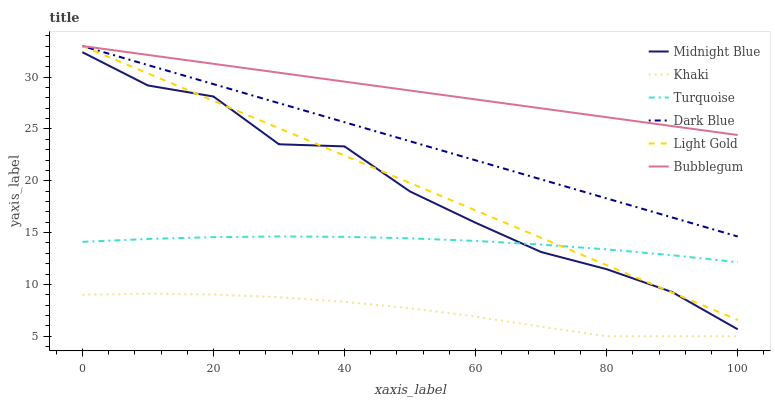Does Khaki have the minimum area under the curve?
Answer yes or no. Yes. Does Bubblegum have the maximum area under the curve?
Answer yes or no. Yes. Does Midnight Blue have the minimum area under the curve?
Answer yes or no. No. Does Midnight Blue have the maximum area under the curve?
Answer yes or no. No. Is Bubblegum the smoothest?
Answer yes or no. Yes. Is Midnight Blue the roughest?
Answer yes or no. Yes. Is Khaki the smoothest?
Answer yes or no. No. Is Khaki the roughest?
Answer yes or no. No. Does Khaki have the lowest value?
Answer yes or no. Yes. Does Midnight Blue have the lowest value?
Answer yes or no. No. Does Light Gold have the highest value?
Answer yes or no. Yes. Does Midnight Blue have the highest value?
Answer yes or no. No. Is Khaki less than Light Gold?
Answer yes or no. Yes. Is Dark Blue greater than Khaki?
Answer yes or no. Yes. Does Turquoise intersect Midnight Blue?
Answer yes or no. Yes. Is Turquoise less than Midnight Blue?
Answer yes or no. No. Is Turquoise greater than Midnight Blue?
Answer yes or no. No. Does Khaki intersect Light Gold?
Answer yes or no. No. 